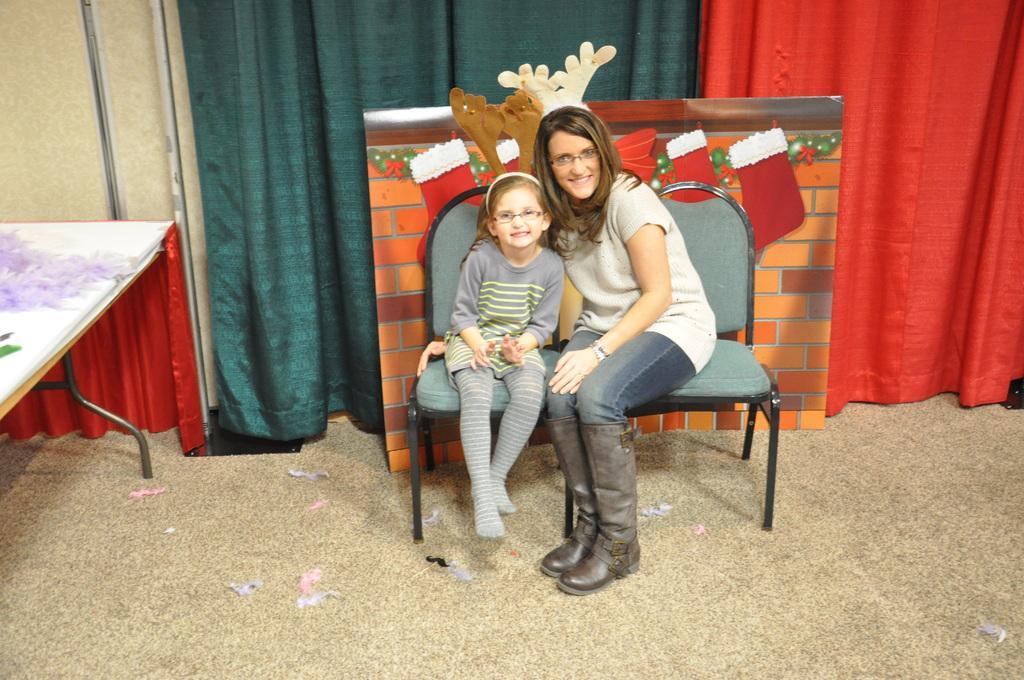Please provide a concise description of this image. A woman and a girl are wearing spectacles and posing to camera. There is cardboard to which red color socks and horns type crafts are attached. There are two curtains. There is a table with some items on it. 